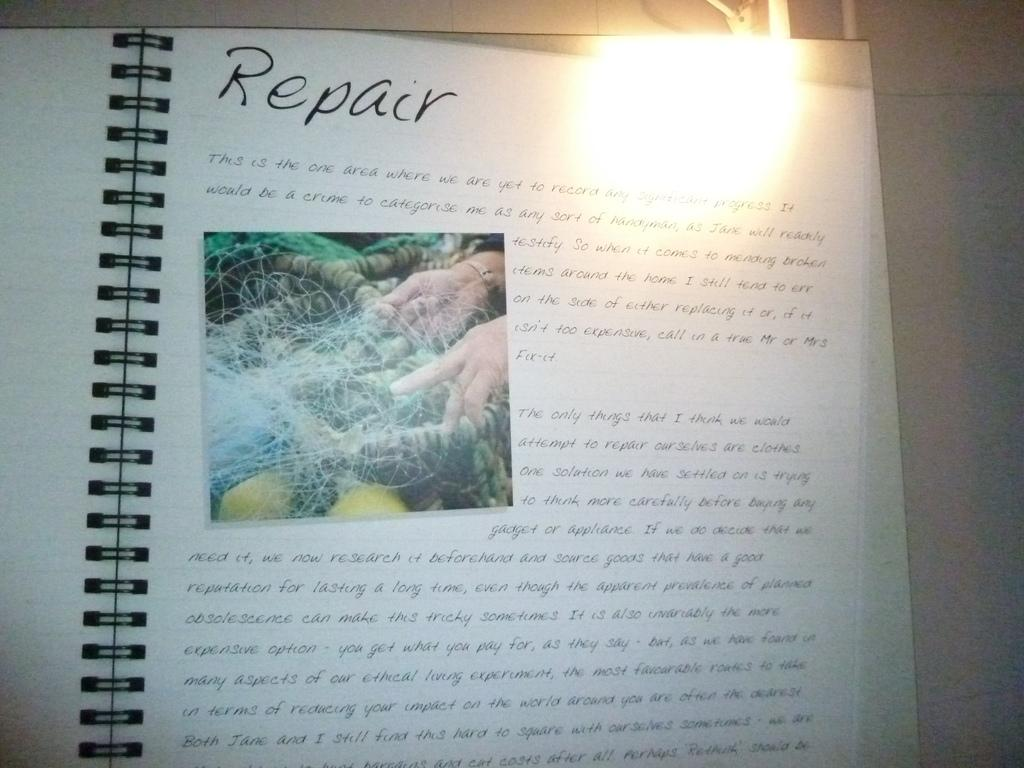<image>
Render a clear and concise summary of the photo. A page about "Repair" has been handwritten in a spiral notebook. 